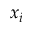Convert formula to latex. <formula><loc_0><loc_0><loc_500><loc_500>x _ { i }</formula> 